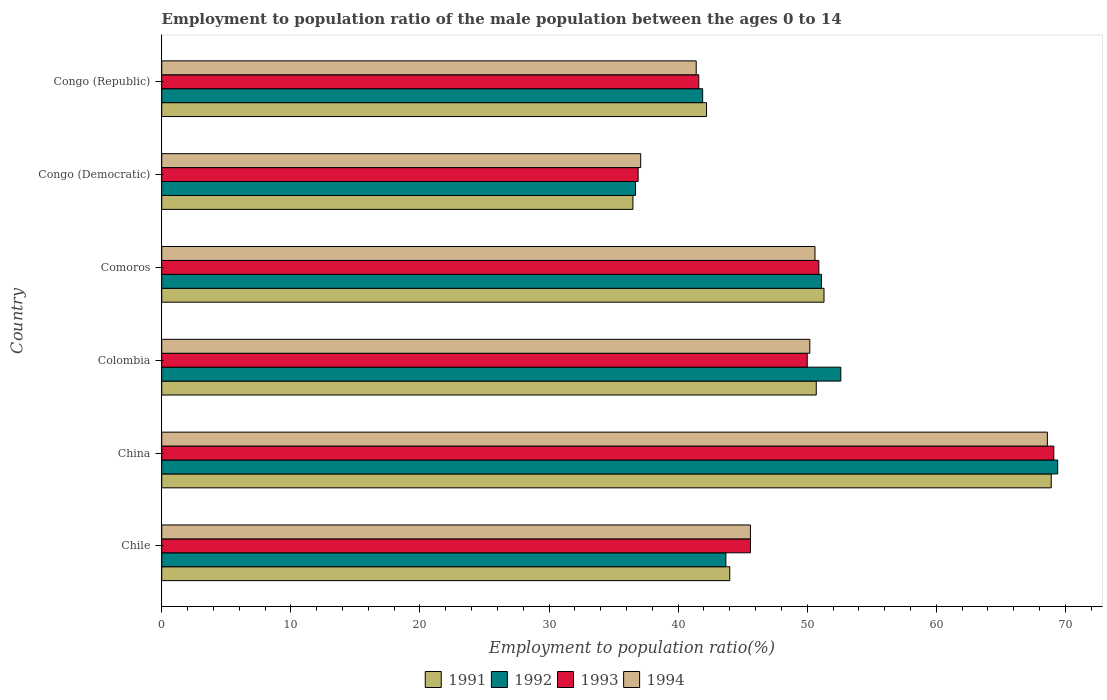How many groups of bars are there?
Your answer should be very brief. 6. Are the number of bars per tick equal to the number of legend labels?
Keep it short and to the point. Yes. How many bars are there on the 1st tick from the top?
Your response must be concise. 4. What is the label of the 1st group of bars from the top?
Keep it short and to the point. Congo (Republic). Across all countries, what is the maximum employment to population ratio in 1993?
Ensure brevity in your answer.  69.1. Across all countries, what is the minimum employment to population ratio in 1992?
Your answer should be very brief. 36.7. In which country was the employment to population ratio in 1992 maximum?
Your answer should be very brief. China. In which country was the employment to population ratio in 1991 minimum?
Your answer should be very brief. Congo (Democratic). What is the total employment to population ratio in 1992 in the graph?
Provide a succinct answer. 295.4. What is the difference between the employment to population ratio in 1993 in China and that in Colombia?
Your answer should be compact. 19.1. What is the difference between the employment to population ratio in 1993 in Congo (Democratic) and the employment to population ratio in 1992 in Comoros?
Provide a short and direct response. -14.2. What is the average employment to population ratio in 1993 per country?
Ensure brevity in your answer.  49.02. What is the difference between the employment to population ratio in 1993 and employment to population ratio in 1991 in Colombia?
Your answer should be very brief. -0.7. In how many countries, is the employment to population ratio in 1994 greater than 62 %?
Your answer should be compact. 1. What is the ratio of the employment to population ratio in 1994 in Comoros to that in Congo (Democratic)?
Provide a succinct answer. 1.36. Is the employment to population ratio in 1992 in Colombia less than that in Congo (Democratic)?
Provide a succinct answer. No. Is the difference between the employment to population ratio in 1993 in Chile and Colombia greater than the difference between the employment to population ratio in 1991 in Chile and Colombia?
Your answer should be very brief. Yes. What is the difference between the highest and the second highest employment to population ratio in 1993?
Provide a succinct answer. 18.2. What is the difference between the highest and the lowest employment to population ratio in 1993?
Your answer should be compact. 32.2. In how many countries, is the employment to population ratio in 1994 greater than the average employment to population ratio in 1994 taken over all countries?
Offer a very short reply. 3. Is it the case that in every country, the sum of the employment to population ratio in 1991 and employment to population ratio in 1994 is greater than the sum of employment to population ratio in 1993 and employment to population ratio in 1992?
Your answer should be compact. No. What does the 3rd bar from the bottom in China represents?
Provide a short and direct response. 1993. Is it the case that in every country, the sum of the employment to population ratio in 1992 and employment to population ratio in 1991 is greater than the employment to population ratio in 1994?
Ensure brevity in your answer.  Yes. How many bars are there?
Your answer should be compact. 24. Are all the bars in the graph horizontal?
Keep it short and to the point. Yes. How many countries are there in the graph?
Offer a very short reply. 6. Where does the legend appear in the graph?
Keep it short and to the point. Bottom center. How many legend labels are there?
Provide a succinct answer. 4. How are the legend labels stacked?
Provide a short and direct response. Horizontal. What is the title of the graph?
Provide a short and direct response. Employment to population ratio of the male population between the ages 0 to 14. What is the Employment to population ratio(%) in 1992 in Chile?
Make the answer very short. 43.7. What is the Employment to population ratio(%) in 1993 in Chile?
Your answer should be very brief. 45.6. What is the Employment to population ratio(%) in 1994 in Chile?
Provide a succinct answer. 45.6. What is the Employment to population ratio(%) in 1991 in China?
Offer a terse response. 68.9. What is the Employment to population ratio(%) of 1992 in China?
Provide a succinct answer. 69.4. What is the Employment to population ratio(%) in 1993 in China?
Offer a very short reply. 69.1. What is the Employment to population ratio(%) in 1994 in China?
Your response must be concise. 68.6. What is the Employment to population ratio(%) in 1991 in Colombia?
Provide a succinct answer. 50.7. What is the Employment to population ratio(%) in 1992 in Colombia?
Make the answer very short. 52.6. What is the Employment to population ratio(%) in 1994 in Colombia?
Provide a succinct answer. 50.2. What is the Employment to population ratio(%) in 1991 in Comoros?
Your answer should be very brief. 51.3. What is the Employment to population ratio(%) in 1992 in Comoros?
Make the answer very short. 51.1. What is the Employment to population ratio(%) of 1993 in Comoros?
Provide a succinct answer. 50.9. What is the Employment to population ratio(%) in 1994 in Comoros?
Offer a very short reply. 50.6. What is the Employment to population ratio(%) of 1991 in Congo (Democratic)?
Provide a succinct answer. 36.5. What is the Employment to population ratio(%) in 1992 in Congo (Democratic)?
Your response must be concise. 36.7. What is the Employment to population ratio(%) of 1993 in Congo (Democratic)?
Make the answer very short. 36.9. What is the Employment to population ratio(%) in 1994 in Congo (Democratic)?
Keep it short and to the point. 37.1. What is the Employment to population ratio(%) in 1991 in Congo (Republic)?
Provide a short and direct response. 42.2. What is the Employment to population ratio(%) in 1992 in Congo (Republic)?
Make the answer very short. 41.9. What is the Employment to population ratio(%) of 1993 in Congo (Republic)?
Offer a terse response. 41.6. What is the Employment to population ratio(%) in 1994 in Congo (Republic)?
Your answer should be very brief. 41.4. Across all countries, what is the maximum Employment to population ratio(%) of 1991?
Your answer should be compact. 68.9. Across all countries, what is the maximum Employment to population ratio(%) of 1992?
Your answer should be compact. 69.4. Across all countries, what is the maximum Employment to population ratio(%) in 1993?
Offer a terse response. 69.1. Across all countries, what is the maximum Employment to population ratio(%) in 1994?
Give a very brief answer. 68.6. Across all countries, what is the minimum Employment to population ratio(%) in 1991?
Provide a succinct answer. 36.5. Across all countries, what is the minimum Employment to population ratio(%) in 1992?
Offer a very short reply. 36.7. Across all countries, what is the minimum Employment to population ratio(%) in 1993?
Provide a short and direct response. 36.9. Across all countries, what is the minimum Employment to population ratio(%) of 1994?
Give a very brief answer. 37.1. What is the total Employment to population ratio(%) of 1991 in the graph?
Make the answer very short. 293.6. What is the total Employment to population ratio(%) in 1992 in the graph?
Your response must be concise. 295.4. What is the total Employment to population ratio(%) in 1993 in the graph?
Ensure brevity in your answer.  294.1. What is the total Employment to population ratio(%) of 1994 in the graph?
Ensure brevity in your answer.  293.5. What is the difference between the Employment to population ratio(%) of 1991 in Chile and that in China?
Your answer should be compact. -24.9. What is the difference between the Employment to population ratio(%) of 1992 in Chile and that in China?
Your answer should be very brief. -25.7. What is the difference between the Employment to population ratio(%) in 1993 in Chile and that in China?
Ensure brevity in your answer.  -23.5. What is the difference between the Employment to population ratio(%) in 1991 in Chile and that in Colombia?
Your answer should be very brief. -6.7. What is the difference between the Employment to population ratio(%) of 1993 in Chile and that in Colombia?
Your answer should be very brief. -4.4. What is the difference between the Employment to population ratio(%) in 1994 in Chile and that in Colombia?
Keep it short and to the point. -4.6. What is the difference between the Employment to population ratio(%) of 1993 in Chile and that in Comoros?
Your answer should be compact. -5.3. What is the difference between the Employment to population ratio(%) in 1991 in Chile and that in Congo (Democratic)?
Make the answer very short. 7.5. What is the difference between the Employment to population ratio(%) in 1991 in Chile and that in Congo (Republic)?
Your response must be concise. 1.8. What is the difference between the Employment to population ratio(%) of 1994 in Chile and that in Congo (Republic)?
Your answer should be compact. 4.2. What is the difference between the Employment to population ratio(%) in 1992 in China and that in Colombia?
Your answer should be very brief. 16.8. What is the difference between the Employment to population ratio(%) in 1993 in China and that in Colombia?
Your answer should be compact. 19.1. What is the difference between the Employment to population ratio(%) of 1994 in China and that in Colombia?
Your response must be concise. 18.4. What is the difference between the Employment to population ratio(%) of 1993 in China and that in Comoros?
Your response must be concise. 18.2. What is the difference between the Employment to population ratio(%) of 1991 in China and that in Congo (Democratic)?
Offer a terse response. 32.4. What is the difference between the Employment to population ratio(%) of 1992 in China and that in Congo (Democratic)?
Your answer should be compact. 32.7. What is the difference between the Employment to population ratio(%) of 1993 in China and that in Congo (Democratic)?
Ensure brevity in your answer.  32.2. What is the difference between the Employment to population ratio(%) in 1994 in China and that in Congo (Democratic)?
Make the answer very short. 31.5. What is the difference between the Employment to population ratio(%) in 1991 in China and that in Congo (Republic)?
Offer a terse response. 26.7. What is the difference between the Employment to population ratio(%) in 1994 in China and that in Congo (Republic)?
Ensure brevity in your answer.  27.2. What is the difference between the Employment to population ratio(%) of 1991 in Colombia and that in Comoros?
Provide a succinct answer. -0.6. What is the difference between the Employment to population ratio(%) of 1992 in Colombia and that in Comoros?
Give a very brief answer. 1.5. What is the difference between the Employment to population ratio(%) in 1993 in Colombia and that in Comoros?
Ensure brevity in your answer.  -0.9. What is the difference between the Employment to population ratio(%) of 1994 in Colombia and that in Comoros?
Your answer should be compact. -0.4. What is the difference between the Employment to population ratio(%) of 1994 in Colombia and that in Congo (Democratic)?
Make the answer very short. 13.1. What is the difference between the Employment to population ratio(%) of 1991 in Colombia and that in Congo (Republic)?
Ensure brevity in your answer.  8.5. What is the difference between the Employment to population ratio(%) in 1992 in Colombia and that in Congo (Republic)?
Offer a very short reply. 10.7. What is the difference between the Employment to population ratio(%) in 1993 in Colombia and that in Congo (Republic)?
Your answer should be compact. 8.4. What is the difference between the Employment to population ratio(%) of 1991 in Comoros and that in Congo (Democratic)?
Offer a very short reply. 14.8. What is the difference between the Employment to population ratio(%) of 1994 in Comoros and that in Congo (Democratic)?
Keep it short and to the point. 13.5. What is the difference between the Employment to population ratio(%) in 1994 in Comoros and that in Congo (Republic)?
Keep it short and to the point. 9.2. What is the difference between the Employment to population ratio(%) of 1992 in Congo (Democratic) and that in Congo (Republic)?
Give a very brief answer. -5.2. What is the difference between the Employment to population ratio(%) of 1993 in Congo (Democratic) and that in Congo (Republic)?
Keep it short and to the point. -4.7. What is the difference between the Employment to population ratio(%) in 1994 in Congo (Democratic) and that in Congo (Republic)?
Make the answer very short. -4.3. What is the difference between the Employment to population ratio(%) in 1991 in Chile and the Employment to population ratio(%) in 1992 in China?
Give a very brief answer. -25.4. What is the difference between the Employment to population ratio(%) of 1991 in Chile and the Employment to population ratio(%) of 1993 in China?
Your answer should be compact. -25.1. What is the difference between the Employment to population ratio(%) of 1991 in Chile and the Employment to population ratio(%) of 1994 in China?
Provide a succinct answer. -24.6. What is the difference between the Employment to population ratio(%) in 1992 in Chile and the Employment to population ratio(%) in 1993 in China?
Ensure brevity in your answer.  -25.4. What is the difference between the Employment to population ratio(%) of 1992 in Chile and the Employment to population ratio(%) of 1994 in China?
Give a very brief answer. -24.9. What is the difference between the Employment to population ratio(%) of 1992 in Chile and the Employment to population ratio(%) of 1993 in Colombia?
Your response must be concise. -6.3. What is the difference between the Employment to population ratio(%) of 1991 in Chile and the Employment to population ratio(%) of 1993 in Comoros?
Provide a short and direct response. -6.9. What is the difference between the Employment to population ratio(%) in 1991 in Chile and the Employment to population ratio(%) in 1994 in Comoros?
Ensure brevity in your answer.  -6.6. What is the difference between the Employment to population ratio(%) in 1992 in Chile and the Employment to population ratio(%) in 1994 in Comoros?
Offer a very short reply. -6.9. What is the difference between the Employment to population ratio(%) in 1992 in Chile and the Employment to population ratio(%) in 1993 in Congo (Democratic)?
Keep it short and to the point. 6.8. What is the difference between the Employment to population ratio(%) in 1991 in Chile and the Employment to population ratio(%) in 1993 in Congo (Republic)?
Give a very brief answer. 2.4. What is the difference between the Employment to population ratio(%) of 1991 in Chile and the Employment to population ratio(%) of 1994 in Congo (Republic)?
Make the answer very short. 2.6. What is the difference between the Employment to population ratio(%) of 1992 in Chile and the Employment to population ratio(%) of 1994 in Congo (Republic)?
Make the answer very short. 2.3. What is the difference between the Employment to population ratio(%) in 1991 in China and the Employment to population ratio(%) in 1992 in Colombia?
Your answer should be compact. 16.3. What is the difference between the Employment to population ratio(%) of 1991 in China and the Employment to population ratio(%) of 1993 in Colombia?
Your response must be concise. 18.9. What is the difference between the Employment to population ratio(%) of 1991 in China and the Employment to population ratio(%) of 1993 in Comoros?
Your answer should be very brief. 18. What is the difference between the Employment to population ratio(%) of 1991 in China and the Employment to population ratio(%) of 1994 in Comoros?
Ensure brevity in your answer.  18.3. What is the difference between the Employment to population ratio(%) of 1992 in China and the Employment to population ratio(%) of 1993 in Comoros?
Ensure brevity in your answer.  18.5. What is the difference between the Employment to population ratio(%) in 1991 in China and the Employment to population ratio(%) in 1992 in Congo (Democratic)?
Your answer should be very brief. 32.2. What is the difference between the Employment to population ratio(%) of 1991 in China and the Employment to population ratio(%) of 1994 in Congo (Democratic)?
Provide a short and direct response. 31.8. What is the difference between the Employment to population ratio(%) of 1992 in China and the Employment to population ratio(%) of 1993 in Congo (Democratic)?
Provide a short and direct response. 32.5. What is the difference between the Employment to population ratio(%) of 1992 in China and the Employment to population ratio(%) of 1994 in Congo (Democratic)?
Offer a very short reply. 32.3. What is the difference between the Employment to population ratio(%) in 1991 in China and the Employment to population ratio(%) in 1993 in Congo (Republic)?
Give a very brief answer. 27.3. What is the difference between the Employment to population ratio(%) of 1991 in China and the Employment to population ratio(%) of 1994 in Congo (Republic)?
Keep it short and to the point. 27.5. What is the difference between the Employment to population ratio(%) in 1992 in China and the Employment to population ratio(%) in 1993 in Congo (Republic)?
Provide a short and direct response. 27.8. What is the difference between the Employment to population ratio(%) in 1992 in China and the Employment to population ratio(%) in 1994 in Congo (Republic)?
Your answer should be very brief. 28. What is the difference between the Employment to population ratio(%) in 1993 in China and the Employment to population ratio(%) in 1994 in Congo (Republic)?
Offer a terse response. 27.7. What is the difference between the Employment to population ratio(%) of 1991 in Colombia and the Employment to population ratio(%) of 1992 in Comoros?
Your answer should be compact. -0.4. What is the difference between the Employment to population ratio(%) in 1992 in Colombia and the Employment to population ratio(%) in 1993 in Comoros?
Ensure brevity in your answer.  1.7. What is the difference between the Employment to population ratio(%) of 1992 in Colombia and the Employment to population ratio(%) of 1994 in Comoros?
Offer a very short reply. 2. What is the difference between the Employment to population ratio(%) in 1991 in Colombia and the Employment to population ratio(%) in 1993 in Congo (Democratic)?
Provide a succinct answer. 13.8. What is the difference between the Employment to population ratio(%) of 1991 in Colombia and the Employment to population ratio(%) of 1992 in Congo (Republic)?
Ensure brevity in your answer.  8.8. What is the difference between the Employment to population ratio(%) of 1991 in Colombia and the Employment to population ratio(%) of 1994 in Congo (Republic)?
Your response must be concise. 9.3. What is the difference between the Employment to population ratio(%) of 1992 in Colombia and the Employment to population ratio(%) of 1994 in Congo (Republic)?
Your answer should be compact. 11.2. What is the difference between the Employment to population ratio(%) of 1991 in Comoros and the Employment to population ratio(%) of 1994 in Congo (Democratic)?
Your response must be concise. 14.2. What is the difference between the Employment to population ratio(%) in 1991 in Comoros and the Employment to population ratio(%) in 1994 in Congo (Republic)?
Provide a succinct answer. 9.9. What is the difference between the Employment to population ratio(%) in 1992 in Comoros and the Employment to population ratio(%) in 1993 in Congo (Republic)?
Your answer should be very brief. 9.5. What is the difference between the Employment to population ratio(%) in 1993 in Comoros and the Employment to population ratio(%) in 1994 in Congo (Republic)?
Your answer should be very brief. 9.5. What is the difference between the Employment to population ratio(%) in 1991 in Congo (Democratic) and the Employment to population ratio(%) in 1992 in Congo (Republic)?
Ensure brevity in your answer.  -5.4. What is the average Employment to population ratio(%) in 1991 per country?
Keep it short and to the point. 48.93. What is the average Employment to population ratio(%) of 1992 per country?
Keep it short and to the point. 49.23. What is the average Employment to population ratio(%) of 1993 per country?
Your answer should be very brief. 49.02. What is the average Employment to population ratio(%) of 1994 per country?
Your answer should be very brief. 48.92. What is the difference between the Employment to population ratio(%) in 1991 and Employment to population ratio(%) in 1993 in Chile?
Give a very brief answer. -1.6. What is the difference between the Employment to population ratio(%) of 1991 and Employment to population ratio(%) of 1994 in Chile?
Ensure brevity in your answer.  -1.6. What is the difference between the Employment to population ratio(%) in 1992 and Employment to population ratio(%) in 1994 in Chile?
Your answer should be very brief. -1.9. What is the difference between the Employment to population ratio(%) of 1992 and Employment to population ratio(%) of 1994 in China?
Your response must be concise. 0.8. What is the difference between the Employment to population ratio(%) in 1991 and Employment to population ratio(%) in 1993 in Colombia?
Provide a succinct answer. 0.7. What is the difference between the Employment to population ratio(%) of 1991 and Employment to population ratio(%) of 1994 in Colombia?
Offer a very short reply. 0.5. What is the difference between the Employment to population ratio(%) of 1992 and Employment to population ratio(%) of 1993 in Colombia?
Your answer should be compact. 2.6. What is the difference between the Employment to population ratio(%) of 1991 and Employment to population ratio(%) of 1992 in Comoros?
Offer a terse response. 0.2. What is the difference between the Employment to population ratio(%) of 1991 and Employment to population ratio(%) of 1993 in Comoros?
Provide a succinct answer. 0.4. What is the difference between the Employment to population ratio(%) in 1991 and Employment to population ratio(%) in 1994 in Comoros?
Keep it short and to the point. 0.7. What is the difference between the Employment to population ratio(%) of 1992 and Employment to population ratio(%) of 1993 in Comoros?
Keep it short and to the point. 0.2. What is the difference between the Employment to population ratio(%) of 1991 and Employment to population ratio(%) of 1993 in Congo (Democratic)?
Ensure brevity in your answer.  -0.4. What is the difference between the Employment to population ratio(%) in 1991 and Employment to population ratio(%) in 1994 in Congo (Democratic)?
Provide a succinct answer. -0.6. What is the difference between the Employment to population ratio(%) of 1992 and Employment to population ratio(%) of 1993 in Congo (Democratic)?
Offer a very short reply. -0.2. What is the difference between the Employment to population ratio(%) of 1992 and Employment to population ratio(%) of 1994 in Congo (Democratic)?
Make the answer very short. -0.4. What is the difference between the Employment to population ratio(%) of 1993 and Employment to population ratio(%) of 1994 in Congo (Democratic)?
Make the answer very short. -0.2. What is the difference between the Employment to population ratio(%) in 1991 and Employment to population ratio(%) in 1993 in Congo (Republic)?
Ensure brevity in your answer.  0.6. What is the difference between the Employment to population ratio(%) of 1991 and Employment to population ratio(%) of 1994 in Congo (Republic)?
Offer a terse response. 0.8. What is the difference between the Employment to population ratio(%) of 1992 and Employment to population ratio(%) of 1993 in Congo (Republic)?
Your response must be concise. 0.3. What is the difference between the Employment to population ratio(%) of 1992 and Employment to population ratio(%) of 1994 in Congo (Republic)?
Your answer should be very brief. 0.5. What is the difference between the Employment to population ratio(%) in 1993 and Employment to population ratio(%) in 1994 in Congo (Republic)?
Ensure brevity in your answer.  0.2. What is the ratio of the Employment to population ratio(%) in 1991 in Chile to that in China?
Offer a terse response. 0.64. What is the ratio of the Employment to population ratio(%) of 1992 in Chile to that in China?
Keep it short and to the point. 0.63. What is the ratio of the Employment to population ratio(%) in 1993 in Chile to that in China?
Keep it short and to the point. 0.66. What is the ratio of the Employment to population ratio(%) of 1994 in Chile to that in China?
Your response must be concise. 0.66. What is the ratio of the Employment to population ratio(%) in 1991 in Chile to that in Colombia?
Give a very brief answer. 0.87. What is the ratio of the Employment to population ratio(%) of 1992 in Chile to that in Colombia?
Provide a succinct answer. 0.83. What is the ratio of the Employment to population ratio(%) in 1993 in Chile to that in Colombia?
Offer a very short reply. 0.91. What is the ratio of the Employment to population ratio(%) in 1994 in Chile to that in Colombia?
Offer a very short reply. 0.91. What is the ratio of the Employment to population ratio(%) in 1991 in Chile to that in Comoros?
Your answer should be very brief. 0.86. What is the ratio of the Employment to population ratio(%) in 1992 in Chile to that in Comoros?
Your answer should be very brief. 0.86. What is the ratio of the Employment to population ratio(%) of 1993 in Chile to that in Comoros?
Your response must be concise. 0.9. What is the ratio of the Employment to population ratio(%) in 1994 in Chile to that in Comoros?
Make the answer very short. 0.9. What is the ratio of the Employment to population ratio(%) of 1991 in Chile to that in Congo (Democratic)?
Keep it short and to the point. 1.21. What is the ratio of the Employment to population ratio(%) in 1992 in Chile to that in Congo (Democratic)?
Provide a short and direct response. 1.19. What is the ratio of the Employment to population ratio(%) of 1993 in Chile to that in Congo (Democratic)?
Offer a terse response. 1.24. What is the ratio of the Employment to population ratio(%) of 1994 in Chile to that in Congo (Democratic)?
Your response must be concise. 1.23. What is the ratio of the Employment to population ratio(%) of 1991 in Chile to that in Congo (Republic)?
Your answer should be very brief. 1.04. What is the ratio of the Employment to population ratio(%) in 1992 in Chile to that in Congo (Republic)?
Ensure brevity in your answer.  1.04. What is the ratio of the Employment to population ratio(%) in 1993 in Chile to that in Congo (Republic)?
Offer a terse response. 1.1. What is the ratio of the Employment to population ratio(%) in 1994 in Chile to that in Congo (Republic)?
Offer a very short reply. 1.1. What is the ratio of the Employment to population ratio(%) in 1991 in China to that in Colombia?
Keep it short and to the point. 1.36. What is the ratio of the Employment to population ratio(%) in 1992 in China to that in Colombia?
Ensure brevity in your answer.  1.32. What is the ratio of the Employment to population ratio(%) in 1993 in China to that in Colombia?
Provide a short and direct response. 1.38. What is the ratio of the Employment to population ratio(%) of 1994 in China to that in Colombia?
Your answer should be compact. 1.37. What is the ratio of the Employment to population ratio(%) in 1991 in China to that in Comoros?
Offer a terse response. 1.34. What is the ratio of the Employment to population ratio(%) of 1992 in China to that in Comoros?
Offer a terse response. 1.36. What is the ratio of the Employment to population ratio(%) in 1993 in China to that in Comoros?
Provide a succinct answer. 1.36. What is the ratio of the Employment to population ratio(%) in 1994 in China to that in Comoros?
Provide a succinct answer. 1.36. What is the ratio of the Employment to population ratio(%) in 1991 in China to that in Congo (Democratic)?
Your response must be concise. 1.89. What is the ratio of the Employment to population ratio(%) of 1992 in China to that in Congo (Democratic)?
Ensure brevity in your answer.  1.89. What is the ratio of the Employment to population ratio(%) in 1993 in China to that in Congo (Democratic)?
Your answer should be compact. 1.87. What is the ratio of the Employment to population ratio(%) of 1994 in China to that in Congo (Democratic)?
Your response must be concise. 1.85. What is the ratio of the Employment to population ratio(%) of 1991 in China to that in Congo (Republic)?
Offer a terse response. 1.63. What is the ratio of the Employment to population ratio(%) in 1992 in China to that in Congo (Republic)?
Your response must be concise. 1.66. What is the ratio of the Employment to population ratio(%) of 1993 in China to that in Congo (Republic)?
Give a very brief answer. 1.66. What is the ratio of the Employment to population ratio(%) in 1994 in China to that in Congo (Republic)?
Make the answer very short. 1.66. What is the ratio of the Employment to population ratio(%) in 1991 in Colombia to that in Comoros?
Offer a terse response. 0.99. What is the ratio of the Employment to population ratio(%) in 1992 in Colombia to that in Comoros?
Your answer should be very brief. 1.03. What is the ratio of the Employment to population ratio(%) of 1993 in Colombia to that in Comoros?
Your answer should be very brief. 0.98. What is the ratio of the Employment to population ratio(%) in 1991 in Colombia to that in Congo (Democratic)?
Give a very brief answer. 1.39. What is the ratio of the Employment to population ratio(%) of 1992 in Colombia to that in Congo (Democratic)?
Your answer should be very brief. 1.43. What is the ratio of the Employment to population ratio(%) in 1993 in Colombia to that in Congo (Democratic)?
Make the answer very short. 1.35. What is the ratio of the Employment to population ratio(%) in 1994 in Colombia to that in Congo (Democratic)?
Provide a succinct answer. 1.35. What is the ratio of the Employment to population ratio(%) of 1991 in Colombia to that in Congo (Republic)?
Your answer should be very brief. 1.2. What is the ratio of the Employment to population ratio(%) of 1992 in Colombia to that in Congo (Republic)?
Offer a very short reply. 1.26. What is the ratio of the Employment to population ratio(%) of 1993 in Colombia to that in Congo (Republic)?
Offer a terse response. 1.2. What is the ratio of the Employment to population ratio(%) of 1994 in Colombia to that in Congo (Republic)?
Keep it short and to the point. 1.21. What is the ratio of the Employment to population ratio(%) in 1991 in Comoros to that in Congo (Democratic)?
Your response must be concise. 1.41. What is the ratio of the Employment to population ratio(%) of 1992 in Comoros to that in Congo (Democratic)?
Ensure brevity in your answer.  1.39. What is the ratio of the Employment to population ratio(%) in 1993 in Comoros to that in Congo (Democratic)?
Provide a succinct answer. 1.38. What is the ratio of the Employment to population ratio(%) in 1994 in Comoros to that in Congo (Democratic)?
Offer a very short reply. 1.36. What is the ratio of the Employment to population ratio(%) in 1991 in Comoros to that in Congo (Republic)?
Ensure brevity in your answer.  1.22. What is the ratio of the Employment to population ratio(%) of 1992 in Comoros to that in Congo (Republic)?
Provide a succinct answer. 1.22. What is the ratio of the Employment to population ratio(%) in 1993 in Comoros to that in Congo (Republic)?
Provide a succinct answer. 1.22. What is the ratio of the Employment to population ratio(%) of 1994 in Comoros to that in Congo (Republic)?
Keep it short and to the point. 1.22. What is the ratio of the Employment to population ratio(%) of 1991 in Congo (Democratic) to that in Congo (Republic)?
Your answer should be very brief. 0.86. What is the ratio of the Employment to population ratio(%) of 1992 in Congo (Democratic) to that in Congo (Republic)?
Give a very brief answer. 0.88. What is the ratio of the Employment to population ratio(%) of 1993 in Congo (Democratic) to that in Congo (Republic)?
Your answer should be compact. 0.89. What is the ratio of the Employment to population ratio(%) of 1994 in Congo (Democratic) to that in Congo (Republic)?
Offer a terse response. 0.9. What is the difference between the highest and the second highest Employment to population ratio(%) in 1991?
Offer a terse response. 17.6. What is the difference between the highest and the lowest Employment to population ratio(%) in 1991?
Your response must be concise. 32.4. What is the difference between the highest and the lowest Employment to population ratio(%) of 1992?
Provide a short and direct response. 32.7. What is the difference between the highest and the lowest Employment to population ratio(%) of 1993?
Provide a succinct answer. 32.2. What is the difference between the highest and the lowest Employment to population ratio(%) in 1994?
Ensure brevity in your answer.  31.5. 